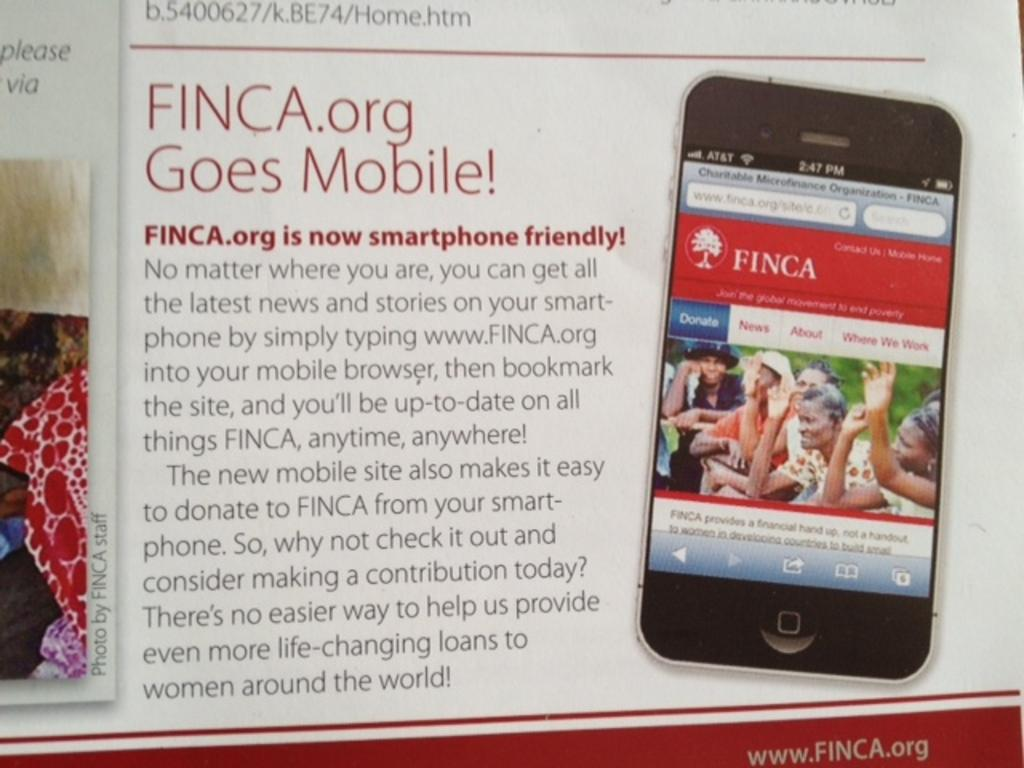<image>
Write a terse but informative summary of the picture. a news item about www. FINCA.org goes mobile 